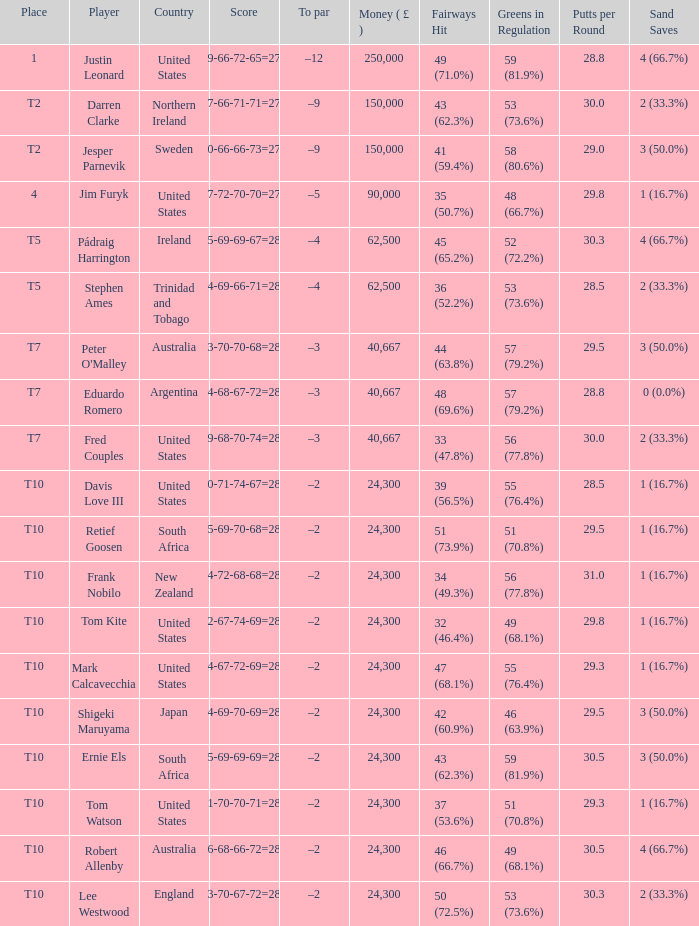What is Lee Westwood's score? 73-70-67-72=282. 